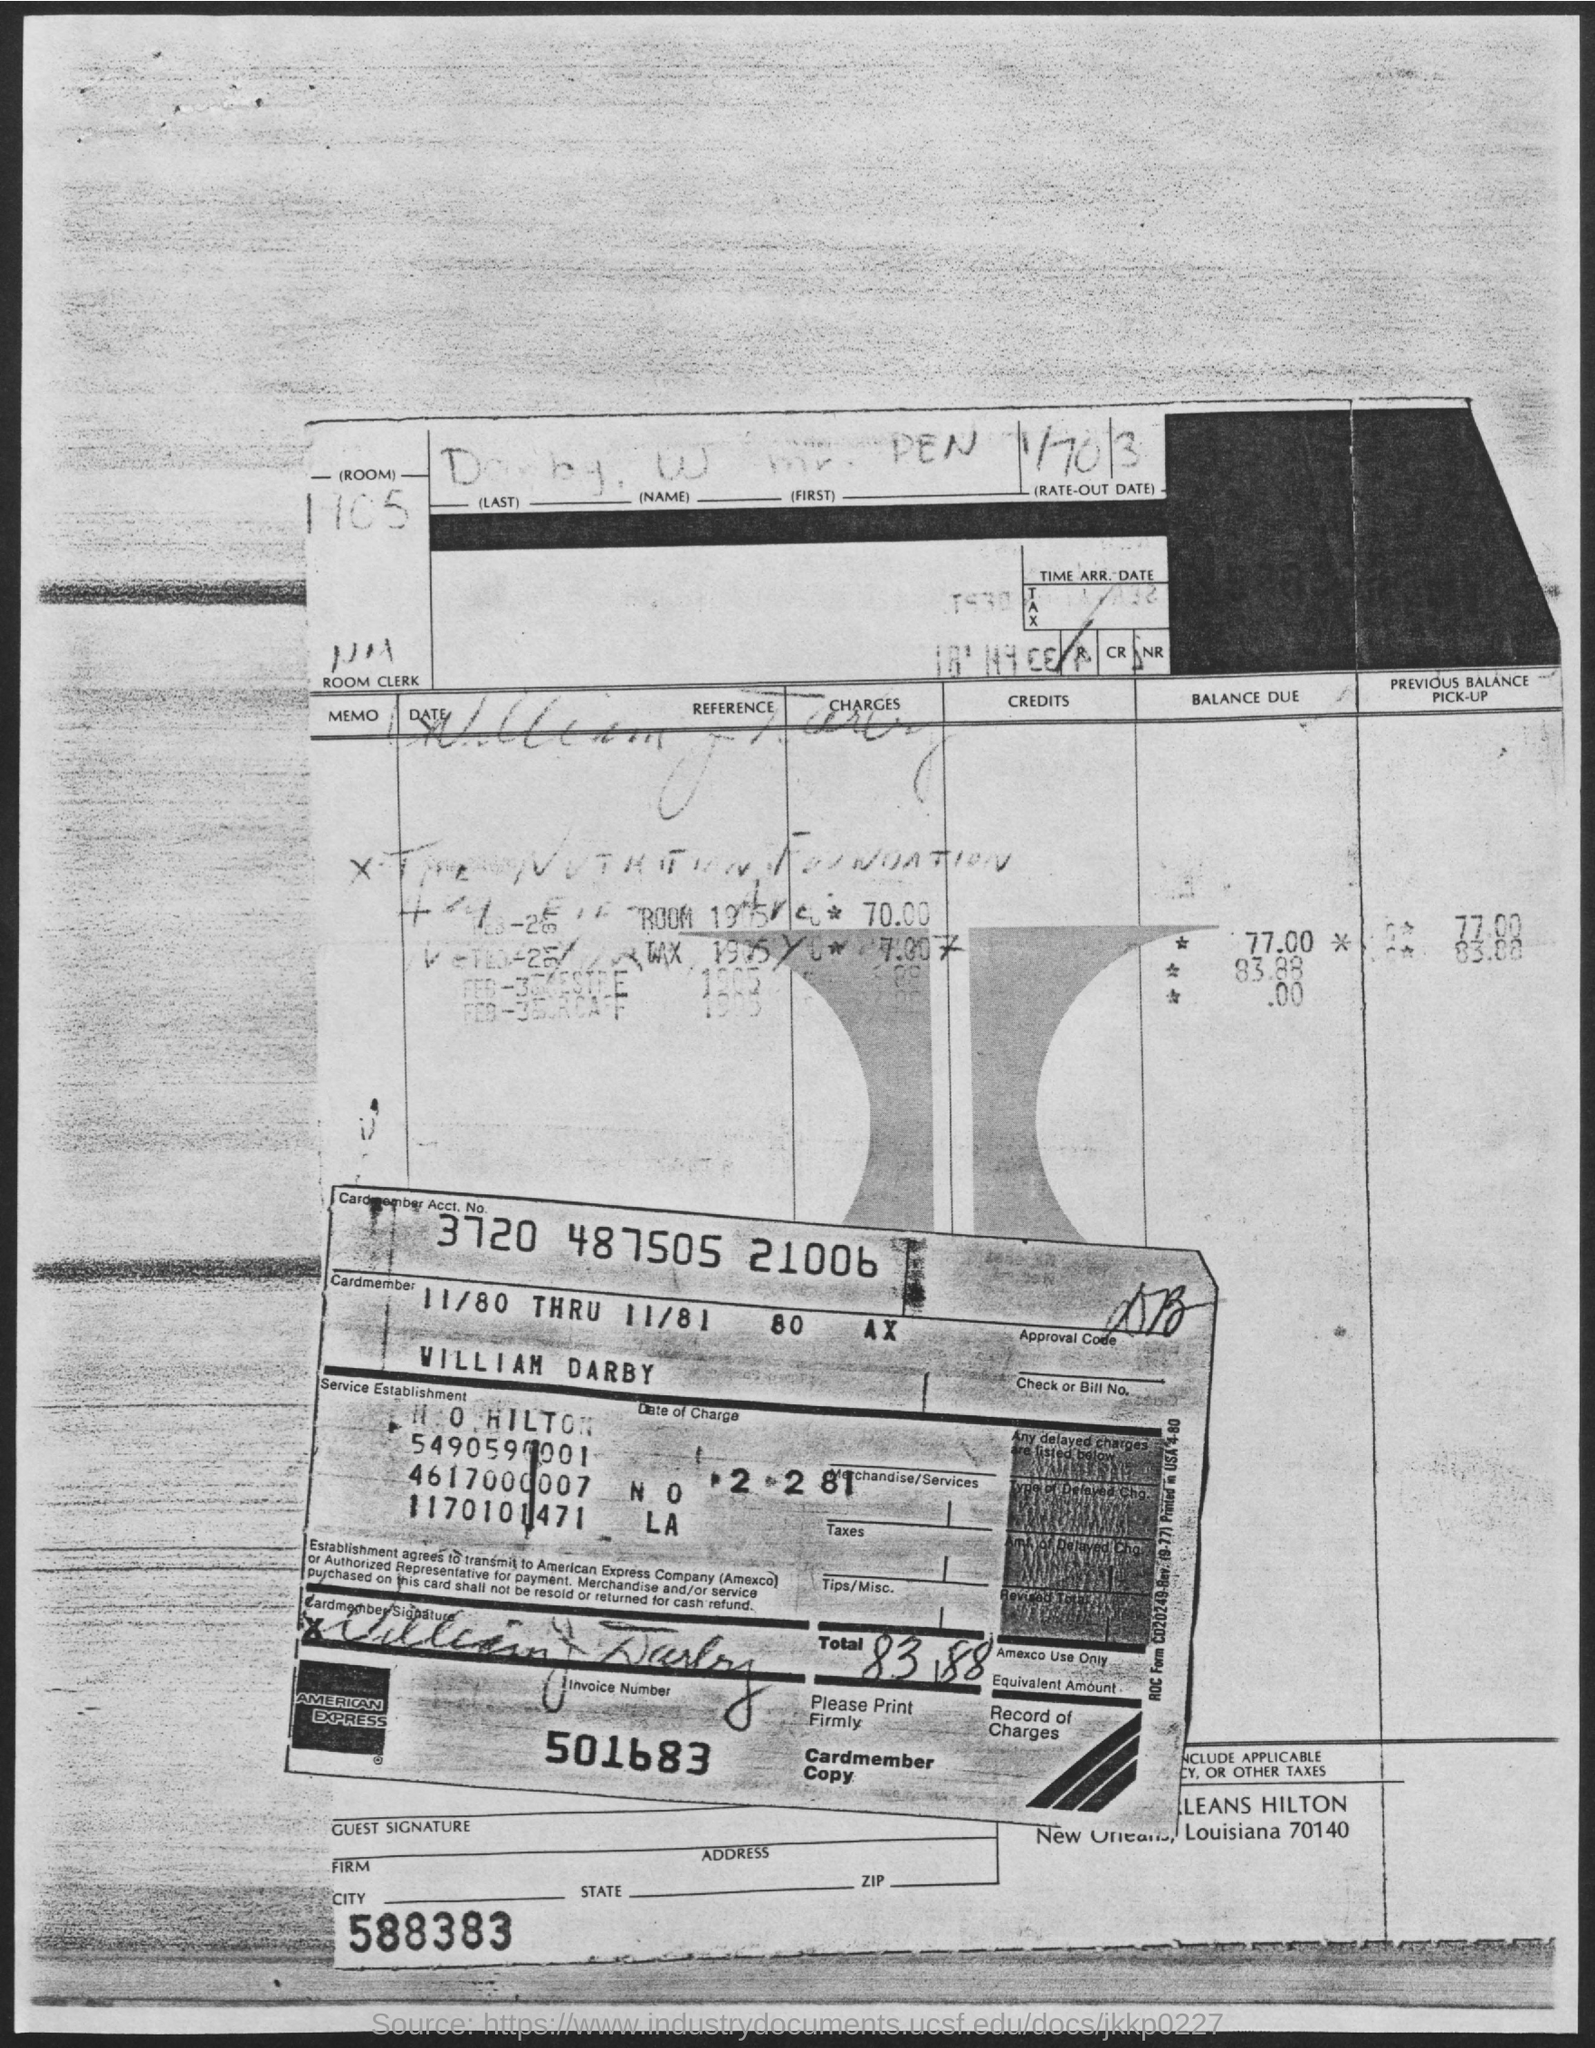Highlight a few significant elements in this photo. What is the invoice number 501683...?" is a question asking for information about a specific invoice number. The Cardmember Account Number is 3720 487505 21006. 